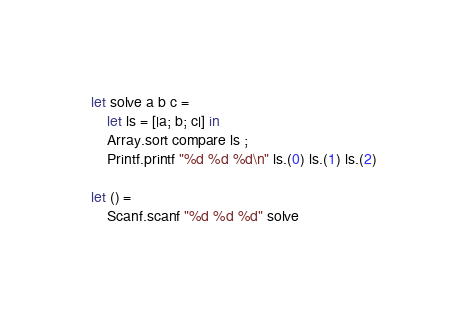<code> <loc_0><loc_0><loc_500><loc_500><_OCaml_>let solve a b c =
    let ls = [|a; b; c|] in
    Array.sort compare ls ;
    Printf.printf "%d %d %d\n" ls.(0) ls.(1) ls.(2)

let () =
    Scanf.scanf "%d %d %d" solve</code> 